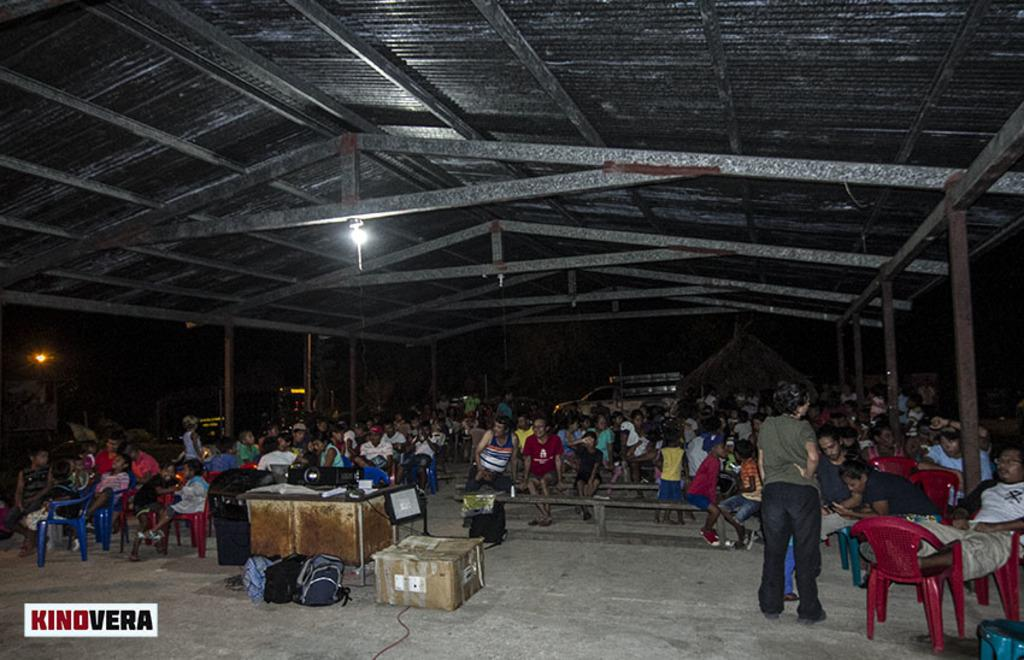What can be seen in the image that provides illumination? There is a light in the image. What are the people in the image doing? The people in the image are sitting and standing. What type of furniture is present in the image? There are chairs and benches in the image. What object in the image might be used for storage? There is a box in the image that might be used for storage. What items in the image might be used for carrying belongings? There are bags in the image that might be used for carrying belongings. What type of music can be heard playing in the image? There is no music present in the image; it only shows a light, people, chairs, benches, a box, and bags. What emotion is the pickle feeling in the image? There are no pickles present in the image, so it is not possible to determine the emotion of a pickle. 